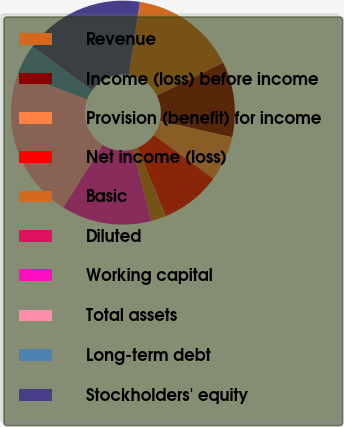<chart> <loc_0><loc_0><loc_500><loc_500><pie_chart><fcel>Revenue<fcel>Income (loss) before income<fcel>Provision (benefit) for income<fcel>Net income (loss)<fcel>Basic<fcel>Diluted<fcel>Working capital<fcel>Total assets<fcel>Long-term debt<fcel>Stockholders' equity<nl><fcel>15.22%<fcel>10.87%<fcel>6.52%<fcel>8.7%<fcel>2.17%<fcel>0.0%<fcel>13.04%<fcel>21.74%<fcel>4.35%<fcel>17.39%<nl></chart> 